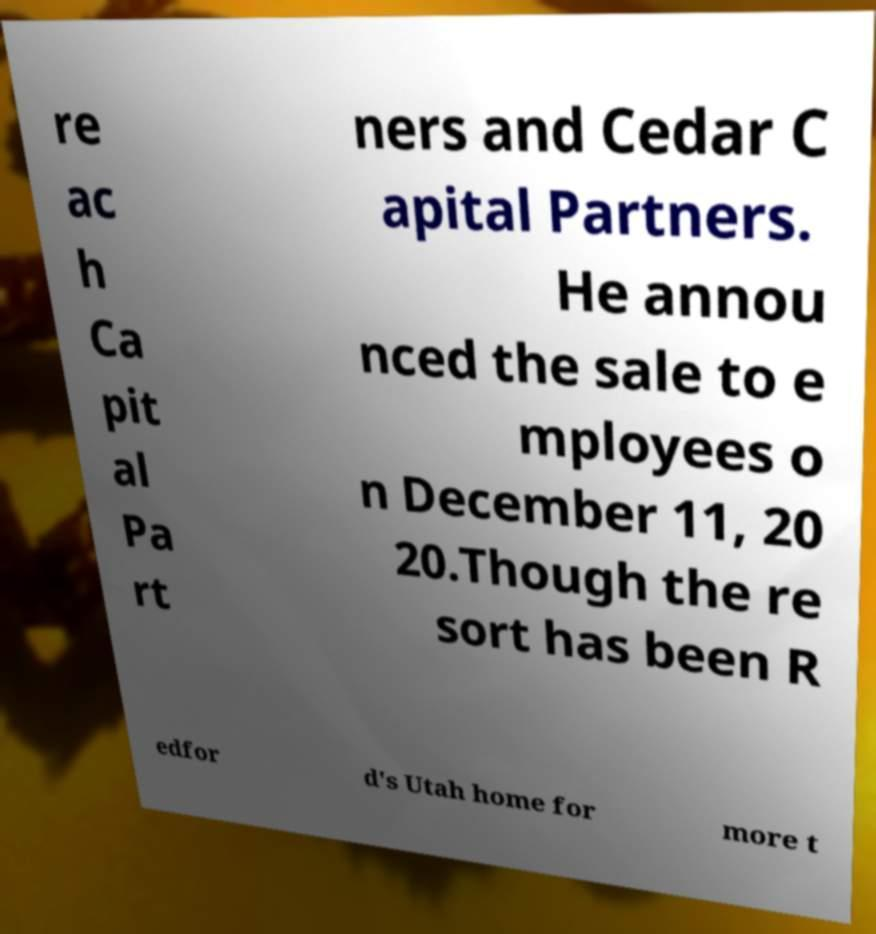For documentation purposes, I need the text within this image transcribed. Could you provide that? re ac h Ca pit al Pa rt ners and Cedar C apital Partners. He annou nced the sale to e mployees o n December 11, 20 20.Though the re sort has been R edfor d's Utah home for more t 